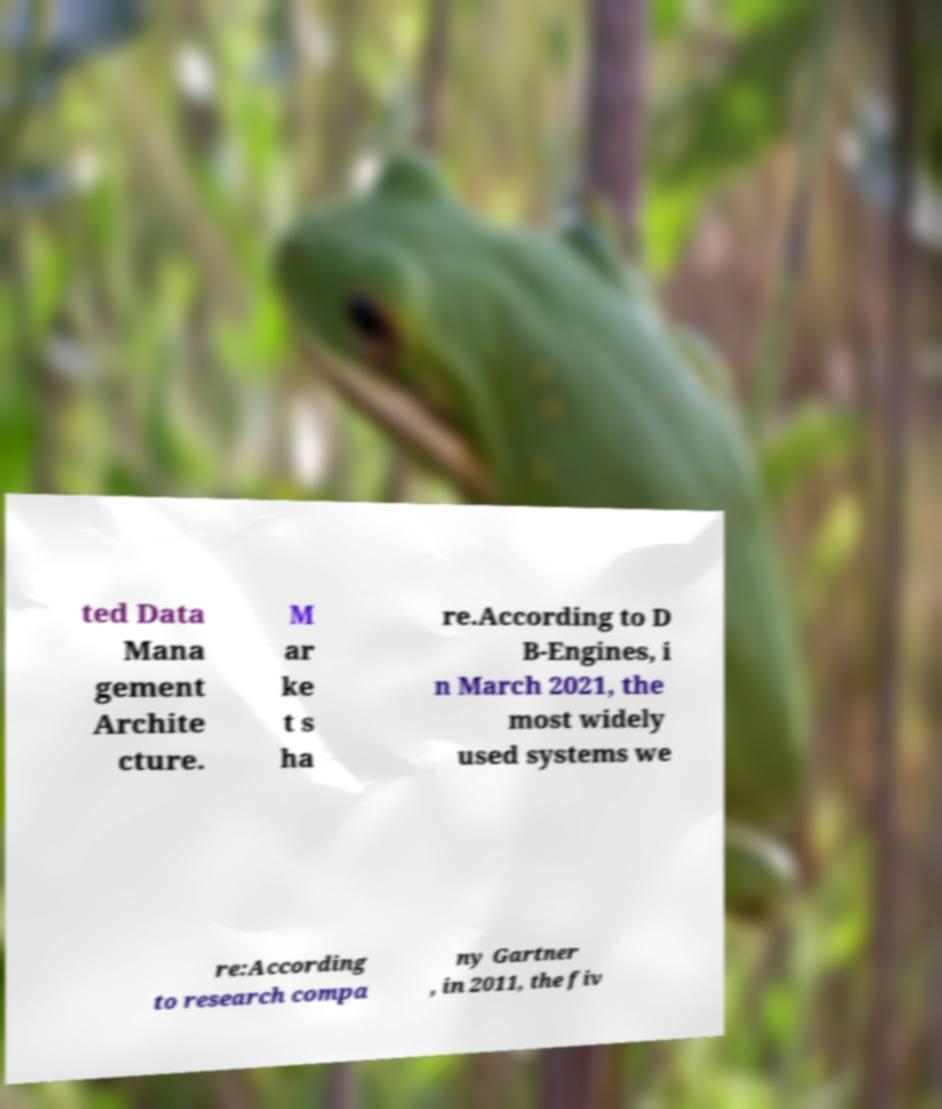What messages or text are displayed in this image? I need them in a readable, typed format. ted Data Mana gement Archite cture. M ar ke t s ha re.According to D B-Engines, i n March 2021, the most widely used systems we re:According to research compa ny Gartner , in 2011, the fiv 